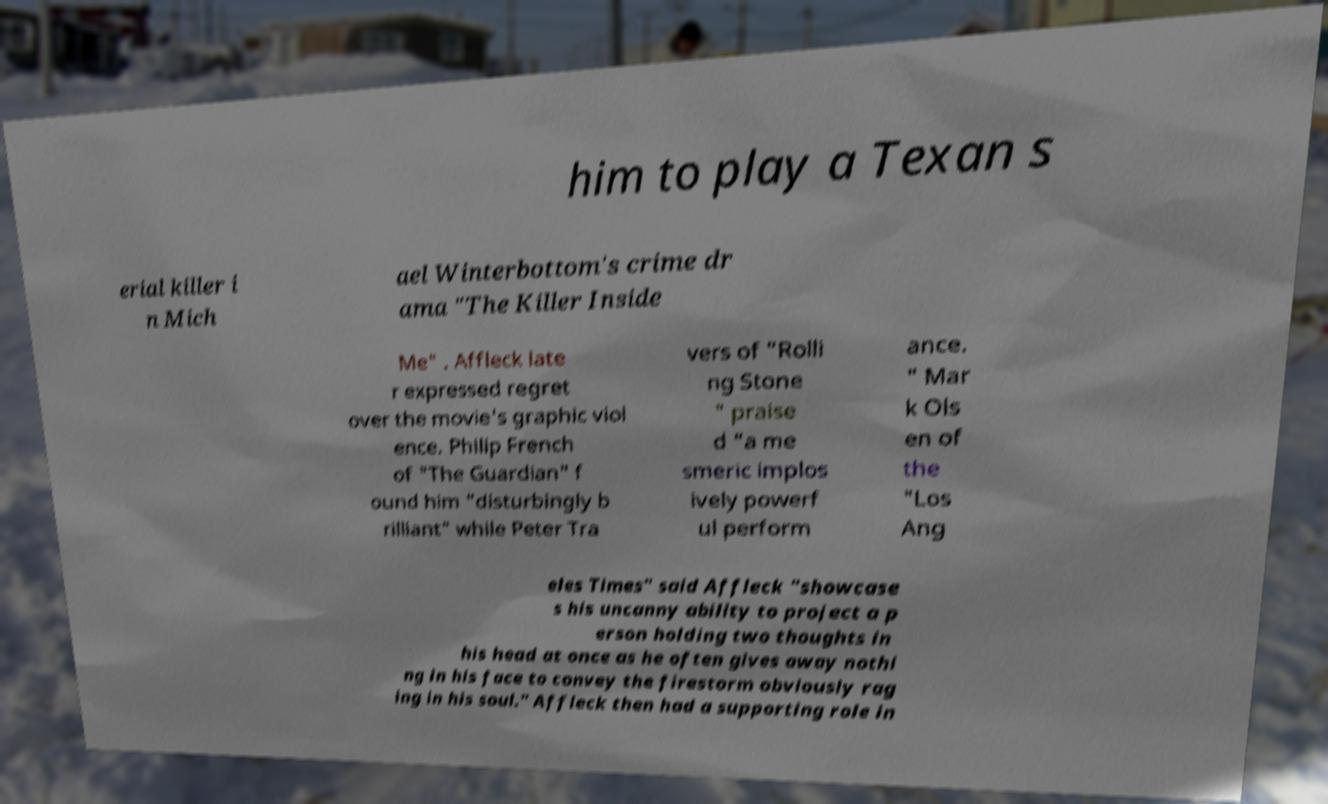Can you read and provide the text displayed in the image?This photo seems to have some interesting text. Can you extract and type it out for me? him to play a Texan s erial killer i n Mich ael Winterbottom's crime dr ama "The Killer Inside Me" . Affleck late r expressed regret over the movie's graphic viol ence. Philip French of "The Guardian" f ound him "disturbingly b rilliant" while Peter Tra vers of "Rolli ng Stone " praise d "a me smeric implos ively powerf ul perform ance. " Mar k Ols en of the "Los Ang eles Times" said Affleck "showcase s his uncanny ability to project a p erson holding two thoughts in his head at once as he often gives away nothi ng in his face to convey the firestorm obviously rag ing in his soul." Affleck then had a supporting role in 